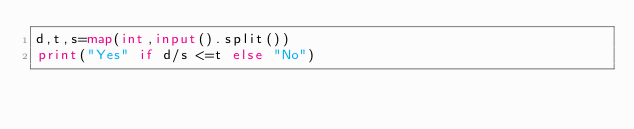<code> <loc_0><loc_0><loc_500><loc_500><_Python_>d,t,s=map(int,input().split())
print("Yes" if d/s <=t else "No")</code> 